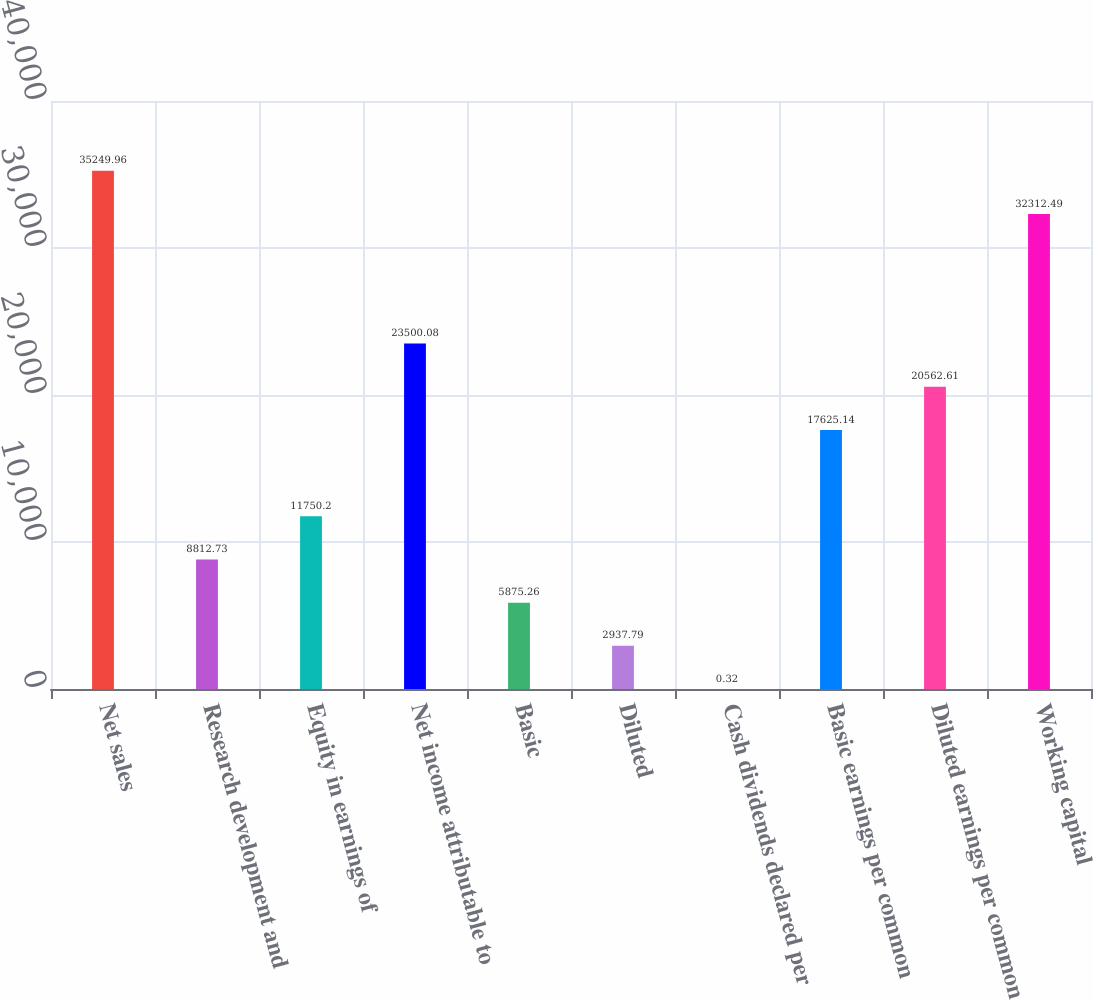<chart> <loc_0><loc_0><loc_500><loc_500><bar_chart><fcel>Net sales<fcel>Research development and<fcel>Equity in earnings of<fcel>Net income attributable to<fcel>Basic<fcel>Diluted<fcel>Cash dividends declared per<fcel>Basic earnings per common<fcel>Diluted earnings per common<fcel>Working capital<nl><fcel>35250<fcel>8812.73<fcel>11750.2<fcel>23500.1<fcel>5875.26<fcel>2937.79<fcel>0.32<fcel>17625.1<fcel>20562.6<fcel>32312.5<nl></chart> 